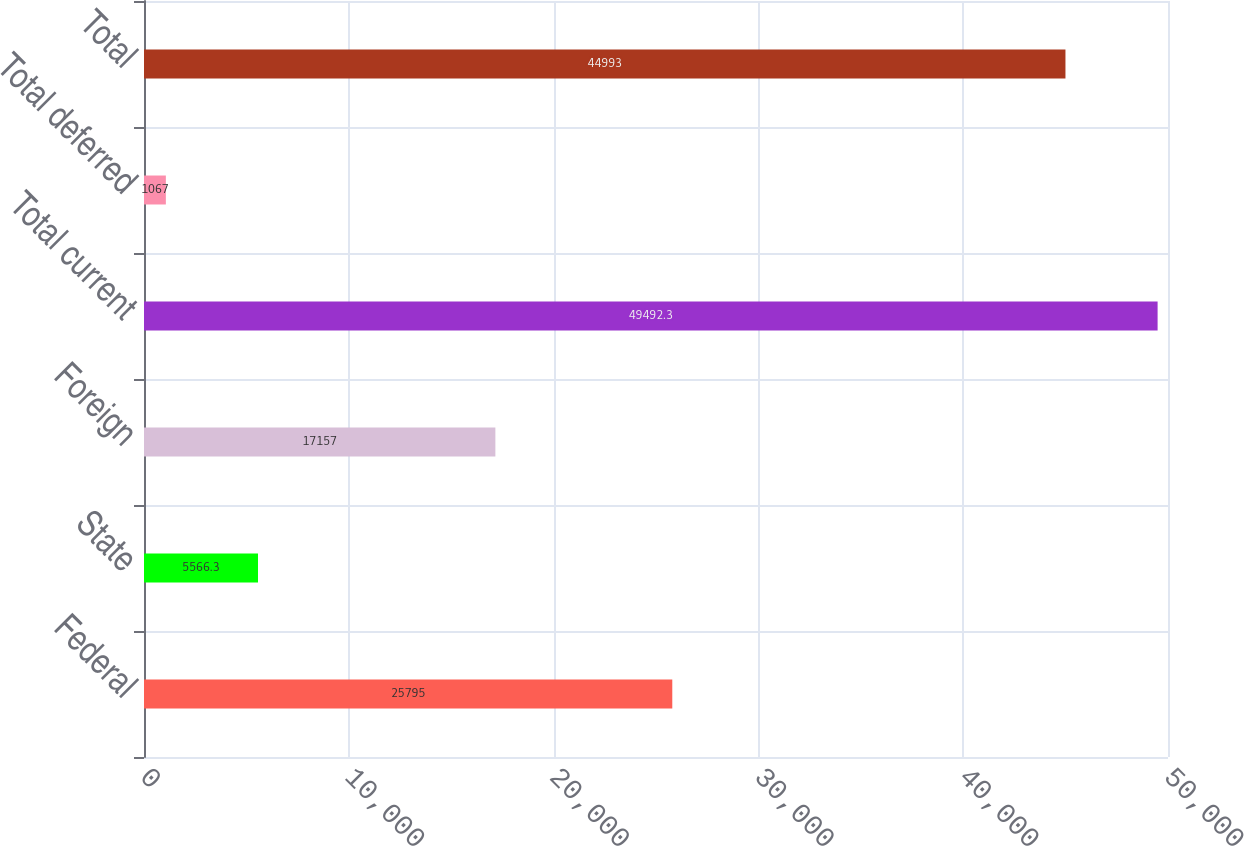Convert chart. <chart><loc_0><loc_0><loc_500><loc_500><bar_chart><fcel>Federal<fcel>State<fcel>Foreign<fcel>Total current<fcel>Total deferred<fcel>Total<nl><fcel>25795<fcel>5566.3<fcel>17157<fcel>49492.3<fcel>1067<fcel>44993<nl></chart> 